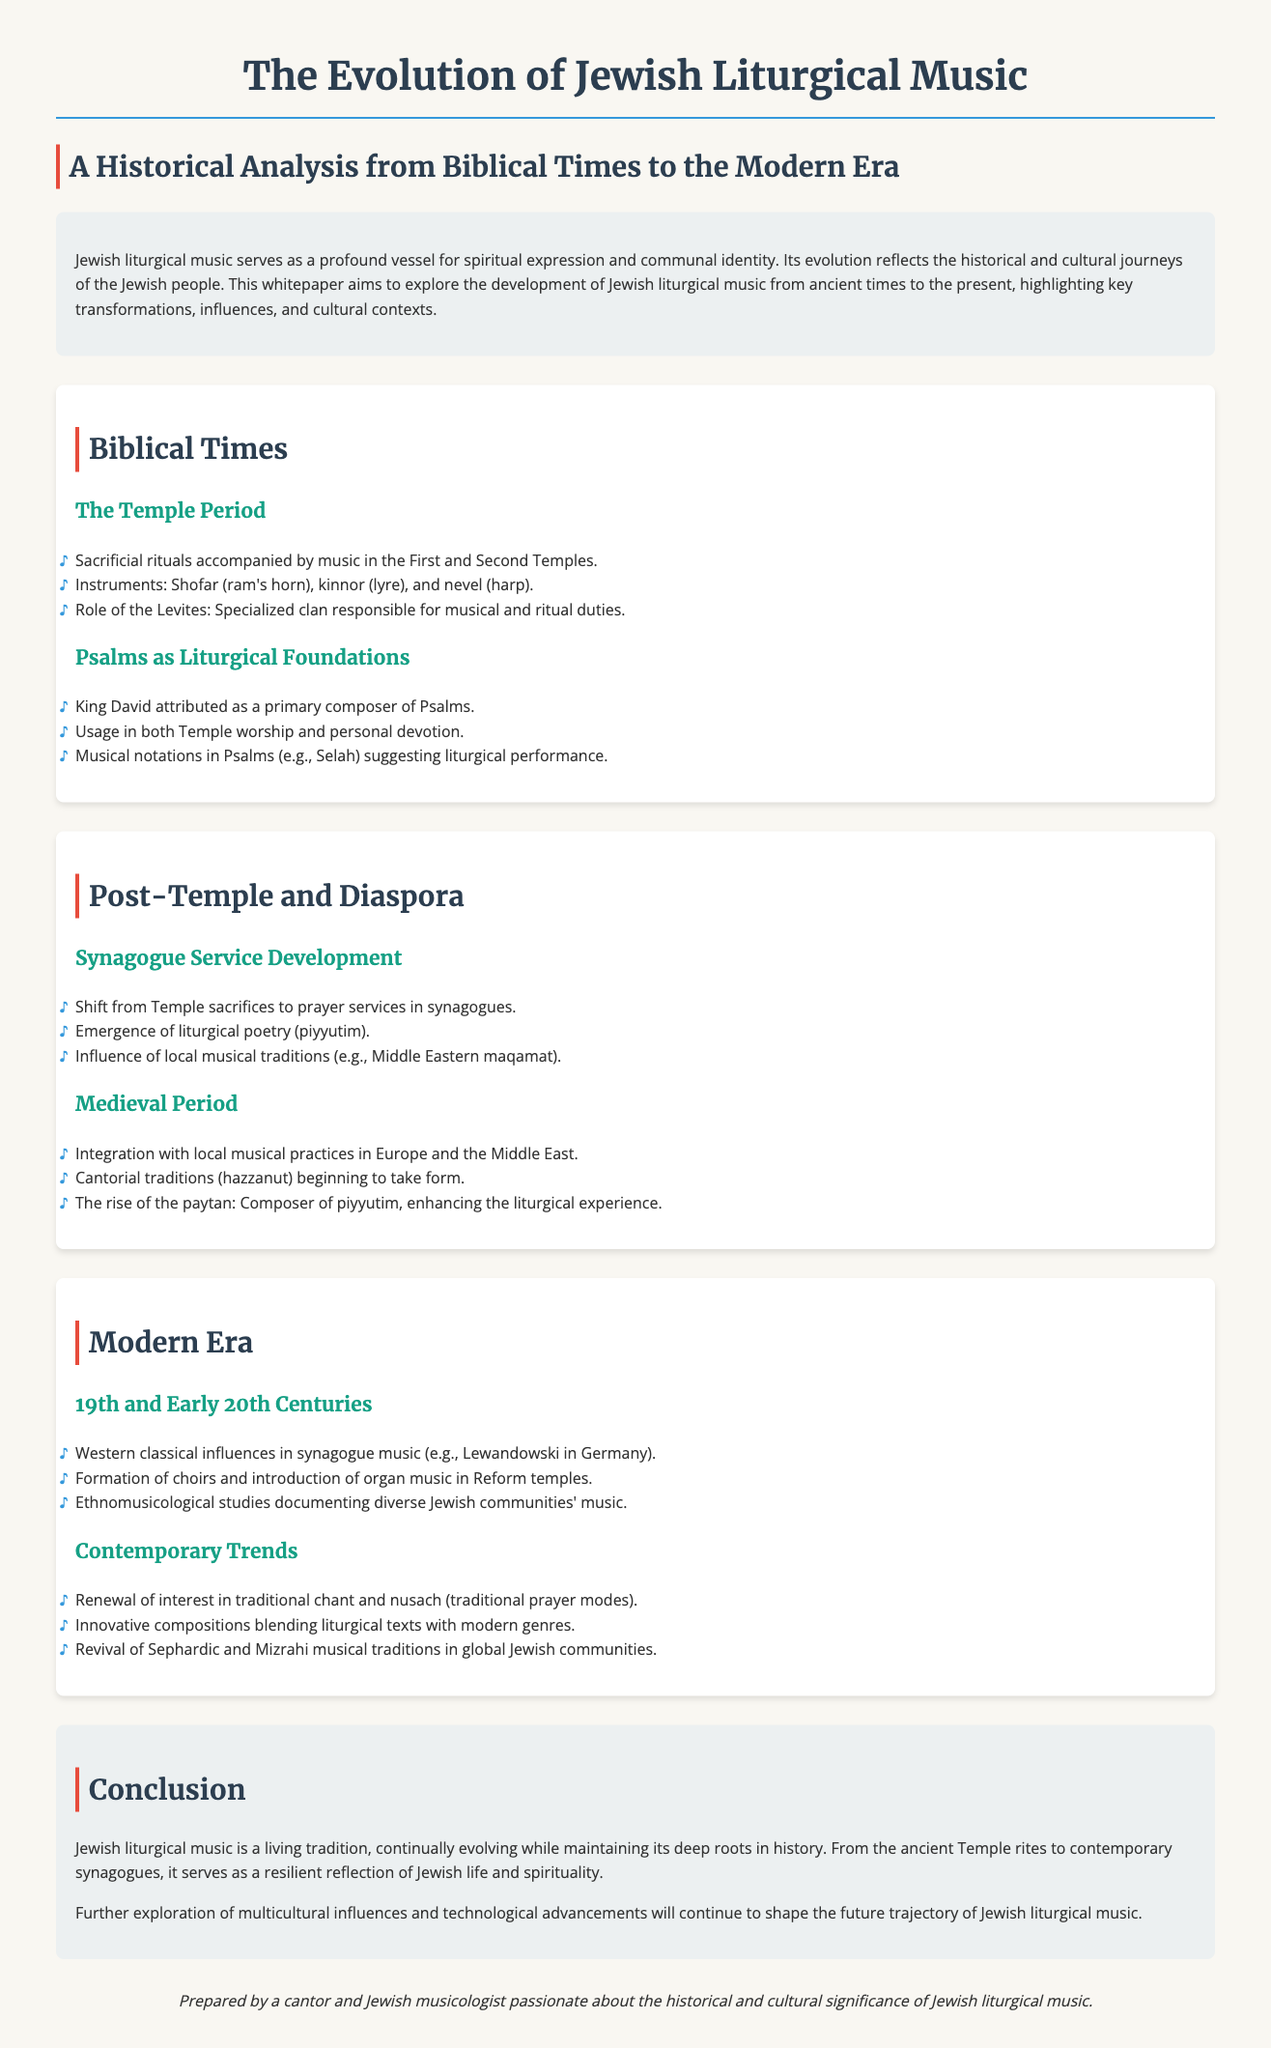What is the title of the whitepaper? The title of the whitepaper is found at the top of the document.
Answer: The Evolution of Jewish Liturgical Music Who is attributed as a primary composer of Psalms? This information is located in the section discussing the importance of Psalms in liturgical music.
Answer: King David What instruments were used during the Temple Period? The document lists specific instruments used during this era in the Biblical Times section.
Answer: Shofar, kinnor, nevel What shift occurred from the Temple to the synagogue services? The document covers the transition from one type of worship to another in the Post-Temple section.
Answer: Shift from Temple sacrifices to prayer services Which century saw Western classical influences in synagogue music? This detail is found in the Modern Era section discussing historical changes in the 19th and early 20th centuries.
Answer: 19th century What term refers to the composers of piyyutim during the Medieval Period? This information is in the section detailing liturgical poetry and its composers.
Answer: Paytan What does the term nusach refer to in contemporary trends? The document mentions this term in the context of modern liturgical practices.
Answer: Traditional prayer modes How does the document describe Jewish liturgical music? The whitepaper provides an overall characterization of Jewish liturgical music in the conclusion.
Answer: A living tradition 